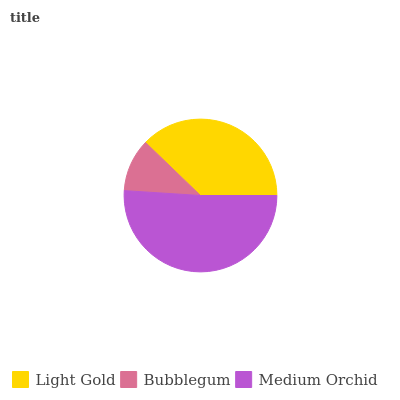Is Bubblegum the minimum?
Answer yes or no. Yes. Is Medium Orchid the maximum?
Answer yes or no. Yes. Is Medium Orchid the minimum?
Answer yes or no. No. Is Bubblegum the maximum?
Answer yes or no. No. Is Medium Orchid greater than Bubblegum?
Answer yes or no. Yes. Is Bubblegum less than Medium Orchid?
Answer yes or no. Yes. Is Bubblegum greater than Medium Orchid?
Answer yes or no. No. Is Medium Orchid less than Bubblegum?
Answer yes or no. No. Is Light Gold the high median?
Answer yes or no. Yes. Is Light Gold the low median?
Answer yes or no. Yes. Is Medium Orchid the high median?
Answer yes or no. No. Is Bubblegum the low median?
Answer yes or no. No. 